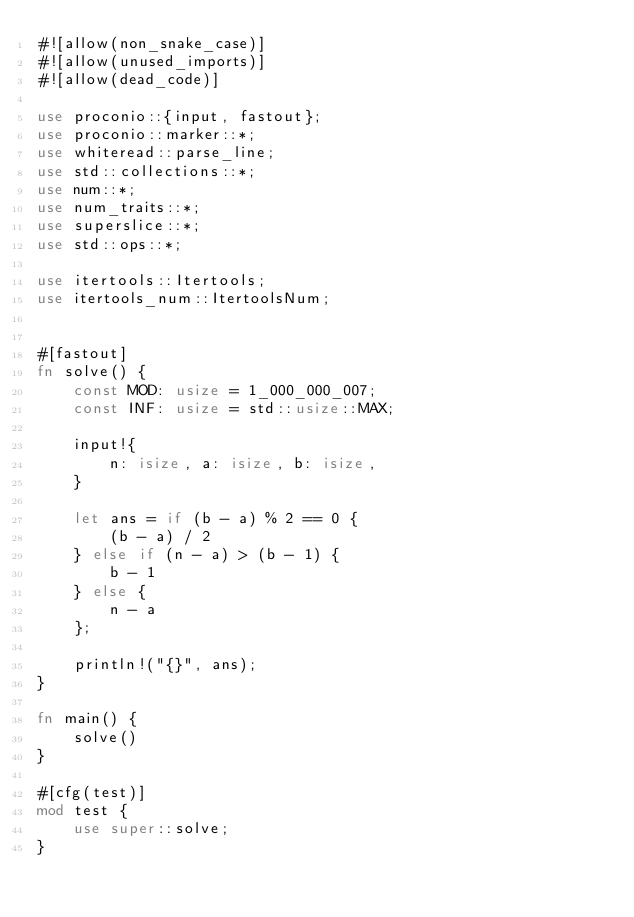<code> <loc_0><loc_0><loc_500><loc_500><_Rust_>#![allow(non_snake_case)]
#![allow(unused_imports)]
#![allow(dead_code)]

use proconio::{input, fastout};
use proconio::marker::*;
use whiteread::parse_line;
use std::collections::*;
use num::*;
use num_traits::*;
use superslice::*;
use std::ops::*;

use itertools::Itertools;
use itertools_num::ItertoolsNum;


#[fastout]
fn solve() {
    const MOD: usize = 1_000_000_007;
    const INF: usize = std::usize::MAX;
    
    input!{
        n: isize, a: isize, b: isize,
    }

    let ans = if (b - a) % 2 == 0 {
        (b - a) / 2
    } else if (n - a) > (b - 1) {
        b - 1
    } else {
        n - a
    };

    println!("{}", ans);
}

fn main() {
    solve()
}

#[cfg(test)]
mod test {
    use super::solve;
}
</code> 